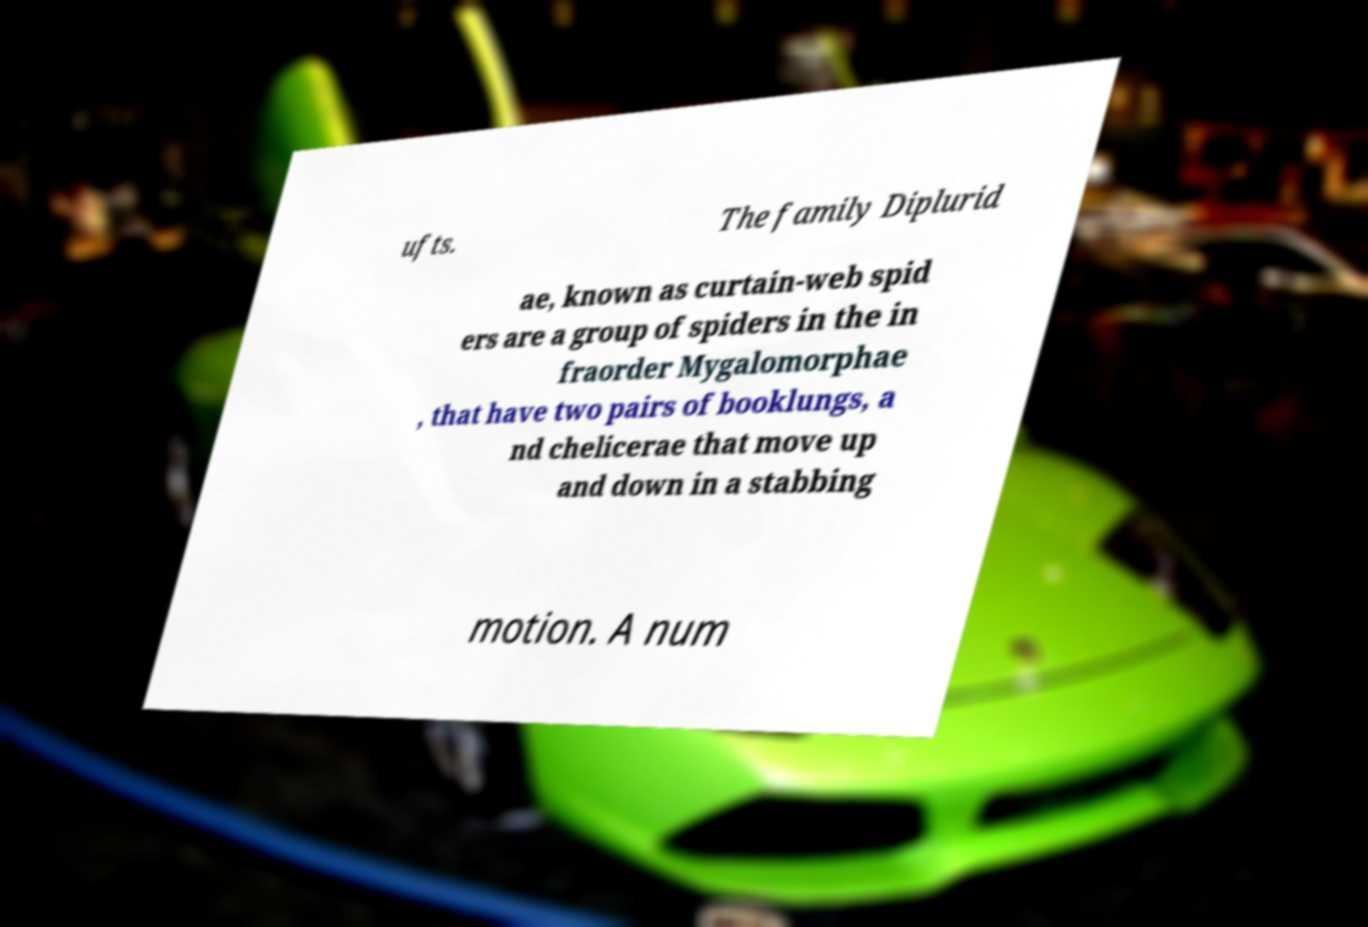For documentation purposes, I need the text within this image transcribed. Could you provide that? ufts. The family Diplurid ae, known as curtain-web spid ers are a group of spiders in the in fraorder Mygalomorphae , that have two pairs of booklungs, a nd chelicerae that move up and down in a stabbing motion. A num 